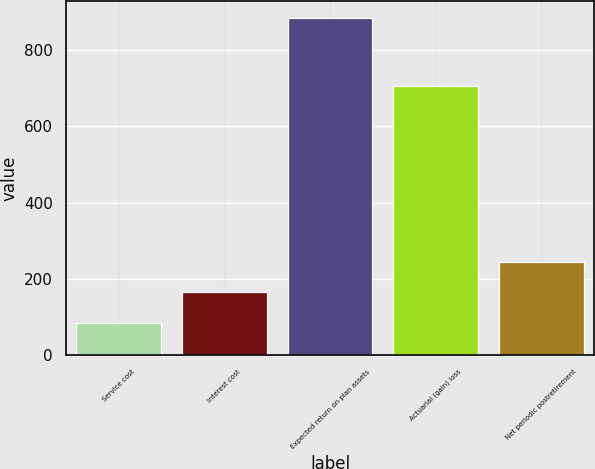<chart> <loc_0><loc_0><loc_500><loc_500><bar_chart><fcel>Service cost<fcel>Interest cost<fcel>Expected return on plan assets<fcel>Actuarial (gain) loss<fcel>Net periodic postretirement<nl><fcel>85<fcel>164.9<fcel>884<fcel>705<fcel>244.8<nl></chart> 